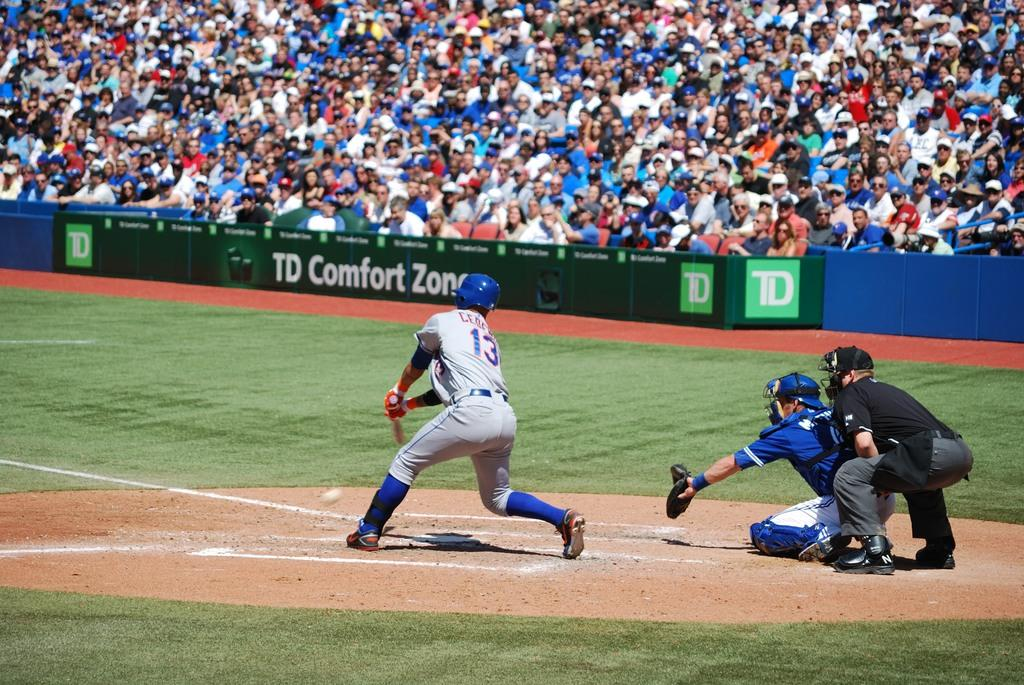Provide a one-sentence caption for the provided image. Baseball stadium with green banner in front of fans that has TD Comfort Zone. 